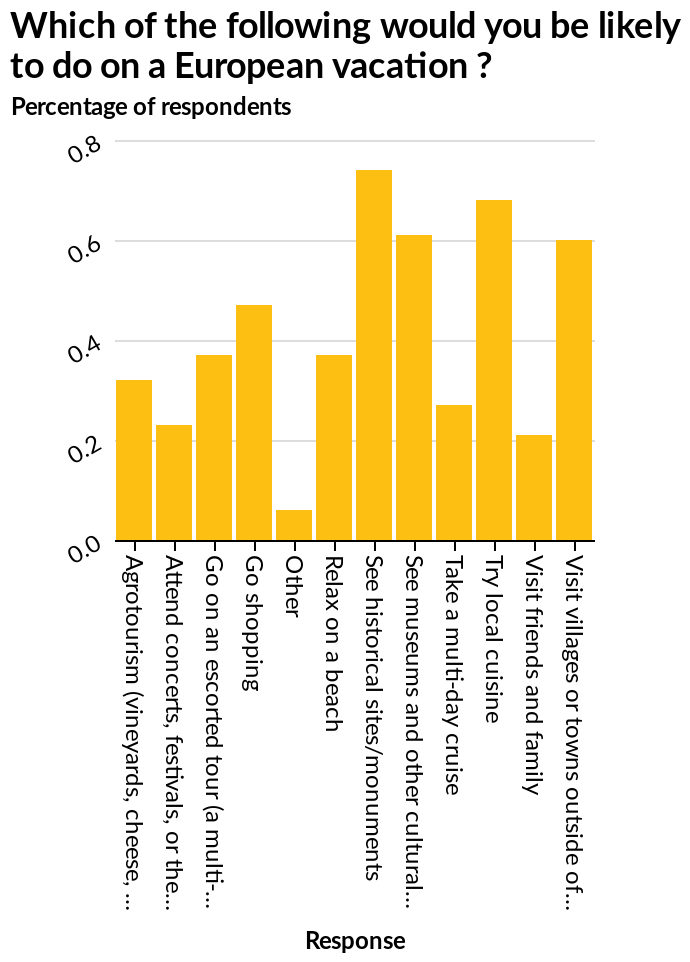<image>
Which places are visited by tourists, according to the bar chart?  The bar chart indicates that tourists visit the local villages and historical sites and museums. 